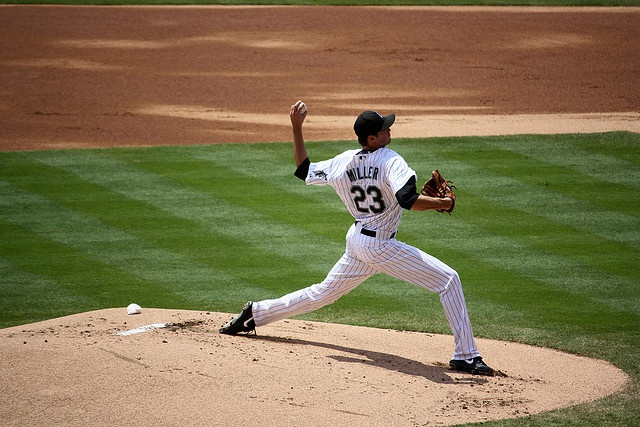Describe the objects in this image and their specific colors. I can see people in darkgreen, darkgray, black, and lavender tones, baseball glove in darkgreen, black, maroon, olive, and brown tones, sports ball in darkgreen, white, darkgray, black, and gray tones, and sports ball in darkgreen, gray, white, and tan tones in this image. 